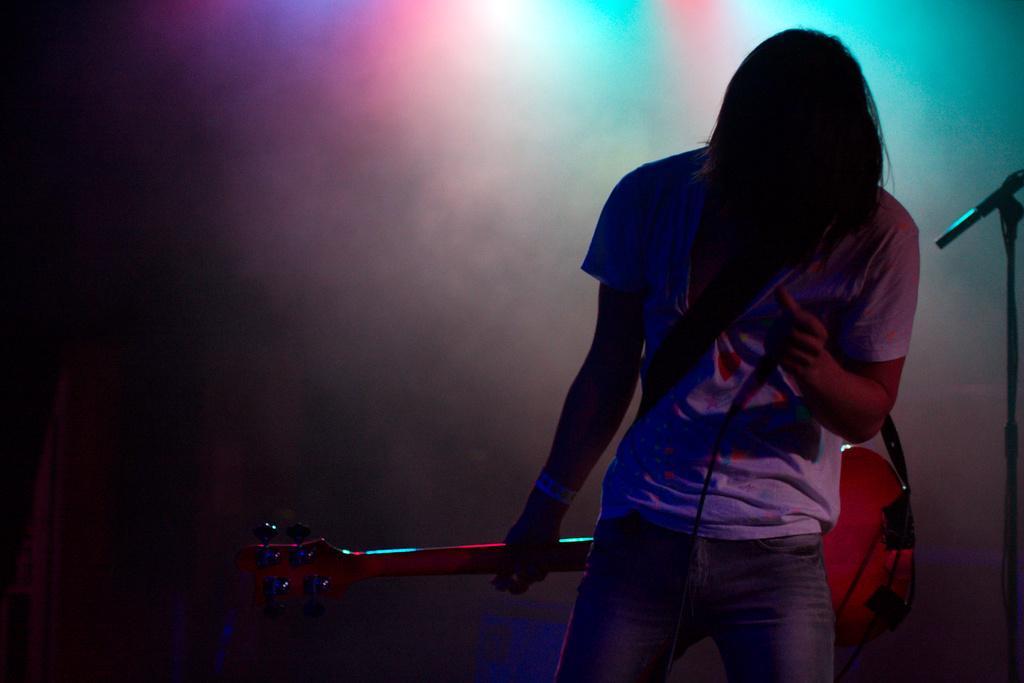Describe this image in one or two sentences. In this image we can see a person holding a guitar and mic. On the right side there is a mic stand. In the background there is smoke and light. 